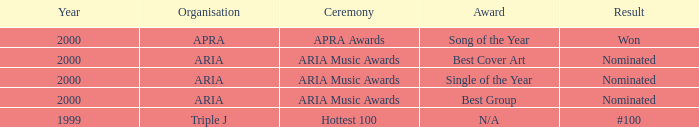What were the results before the year 2000? #100. 